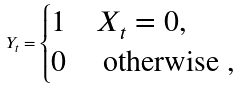Convert formula to latex. <formula><loc_0><loc_0><loc_500><loc_500>Y _ { t } = \begin{cases} 1 & X _ { t } = 0 , \\ 0 & \text { otherwise } , \end{cases}</formula> 